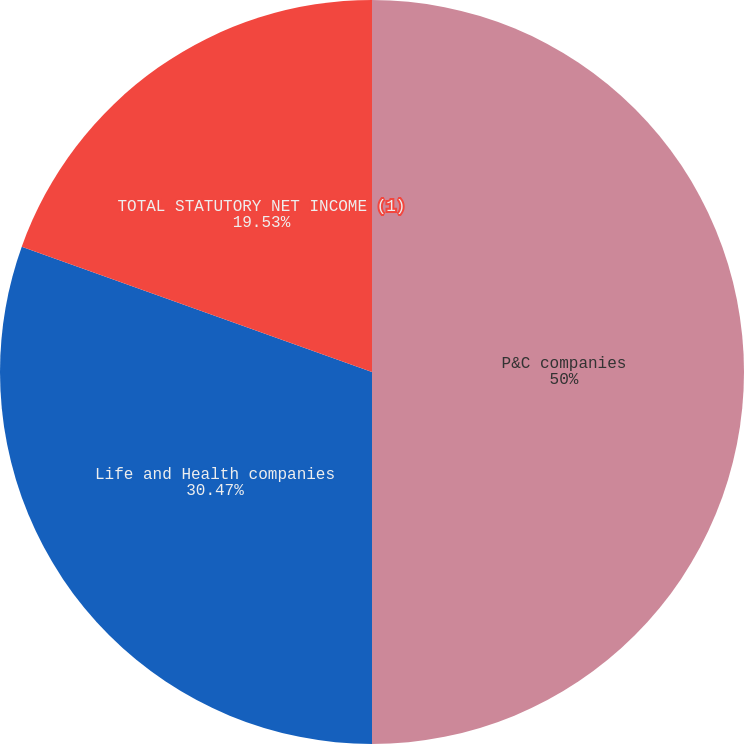Convert chart. <chart><loc_0><loc_0><loc_500><loc_500><pie_chart><fcel>P&C companies<fcel>Life and Health companies<fcel>TOTAL STATUTORY NET INCOME (1)<nl><fcel>50.0%<fcel>30.47%<fcel>19.53%<nl></chart> 